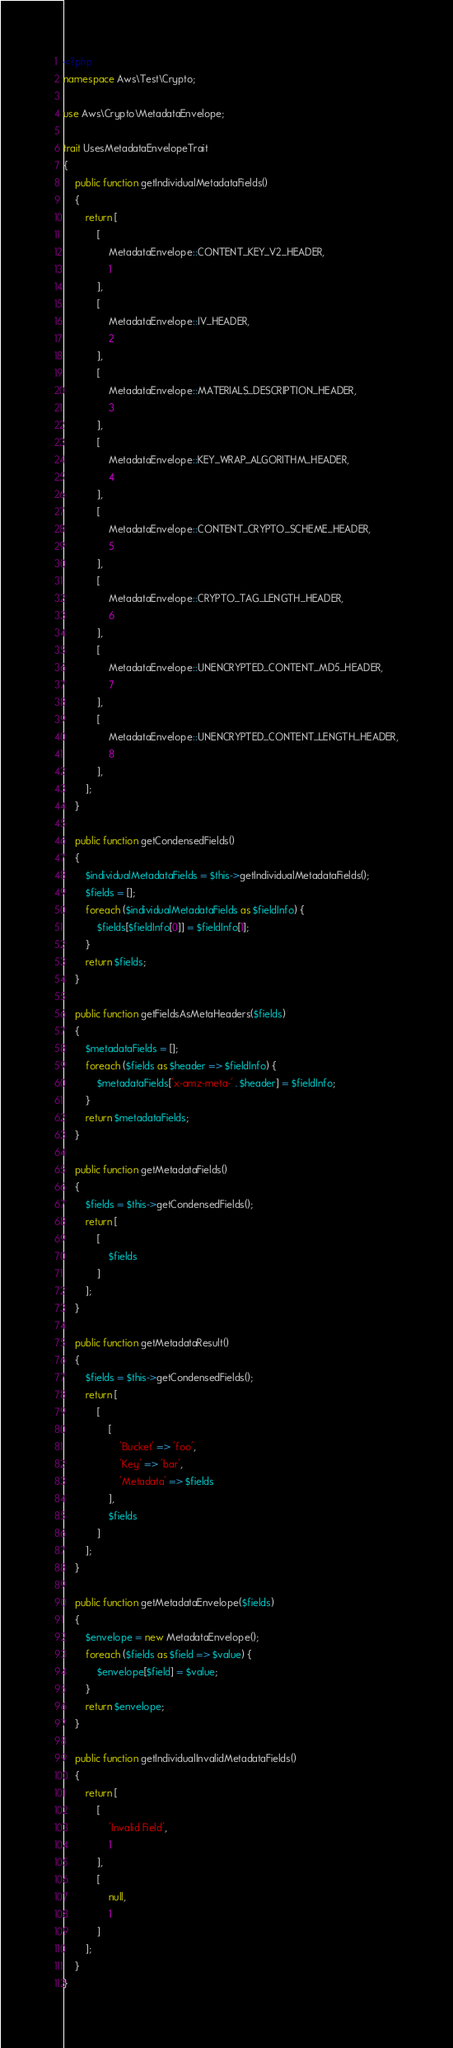<code> <loc_0><loc_0><loc_500><loc_500><_PHP_><?php
namespace Aws\Test\Crypto;

use Aws\Crypto\MetadataEnvelope;

trait UsesMetadataEnvelopeTrait
{
    public function getIndividualMetadataFields()
    {
        return [
            [
                MetadataEnvelope::CONTENT_KEY_V2_HEADER,
                1
            ],
            [
                MetadataEnvelope::IV_HEADER,
                2
            ],
            [
                MetadataEnvelope::MATERIALS_DESCRIPTION_HEADER,
                3
            ],
            [
                MetadataEnvelope::KEY_WRAP_ALGORITHM_HEADER,
                4
            ],
            [
                MetadataEnvelope::CONTENT_CRYPTO_SCHEME_HEADER,
                5
            ],
            [
                MetadataEnvelope::CRYPTO_TAG_LENGTH_HEADER,
                6
            ],
            [
                MetadataEnvelope::UNENCRYPTED_CONTENT_MD5_HEADER,
                7
            ],
            [
                MetadataEnvelope::UNENCRYPTED_CONTENT_LENGTH_HEADER,
                8
            ],
        ];
    }

    public function getCondensedFields()
    {
        $individualMetadataFields = $this->getIndividualMetadataFields();
        $fields = [];
        foreach ($individualMetadataFields as $fieldInfo) {
            $fields[$fieldInfo[0]] = $fieldInfo[1];
        }
        return $fields;
    }

    public function getFieldsAsMetaHeaders($fields)
    {
        $metadataFields = [];
        foreach ($fields as $header => $fieldInfo) {
            $metadataFields['x-amz-meta-' . $header] = $fieldInfo;
        }
        return $metadataFields;
    }

    public function getMetadataFields()
    {
        $fields = $this->getCondensedFields();
        return [
            [
                $fields
            ]
        ];
    }

    public function getMetadataResult()
    {
        $fields = $this->getCondensedFields();
        return [
            [
                [
                    'Bucket' => 'foo',
                    'Key' => 'bar',
                    'Metadata' => $fields
                ],
                $fields
            ]
        ];
    }

    public function getMetadataEnvelope($fields)
    {
        $envelope = new MetadataEnvelope();
        foreach ($fields as $field => $value) {
            $envelope[$field] = $value;
        }
        return $envelope;
    }

    public function getIndividualInvalidMetadataFields()
    {
        return [
            [
                'Invalid Field',
                1
            ],
            [
                null,
                1
            ]
        ];
    }
}
</code> 